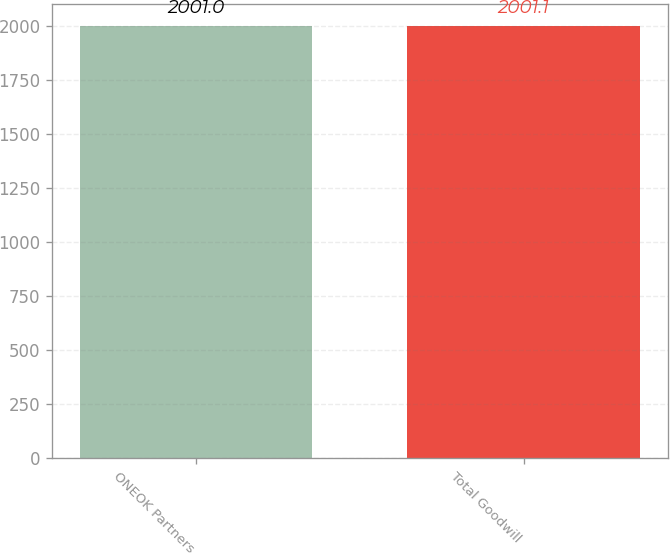<chart> <loc_0><loc_0><loc_500><loc_500><bar_chart><fcel>ONEOK Partners<fcel>Total Goodwill<nl><fcel>2001<fcel>2001.1<nl></chart> 